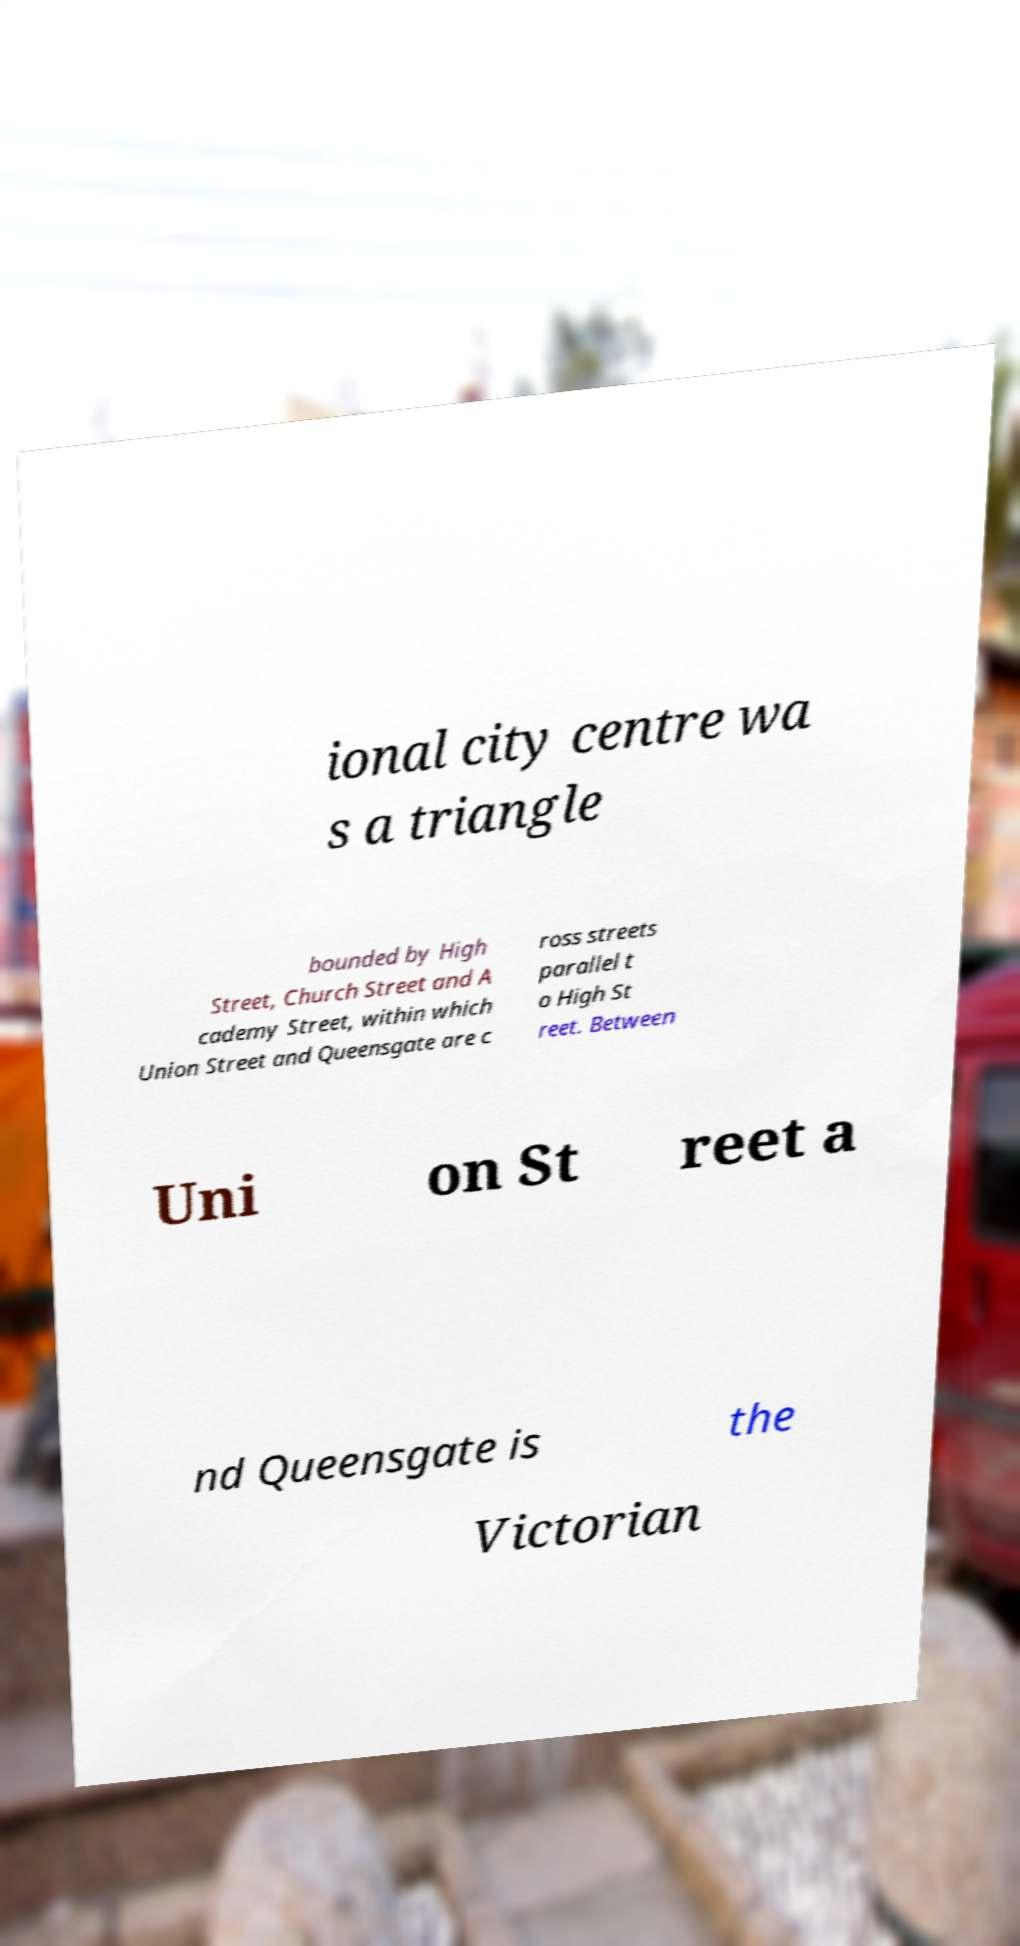Can you accurately transcribe the text from the provided image for me? ional city centre wa s a triangle bounded by High Street, Church Street and A cademy Street, within which Union Street and Queensgate are c ross streets parallel t o High St reet. Between Uni on St reet a nd Queensgate is the Victorian 